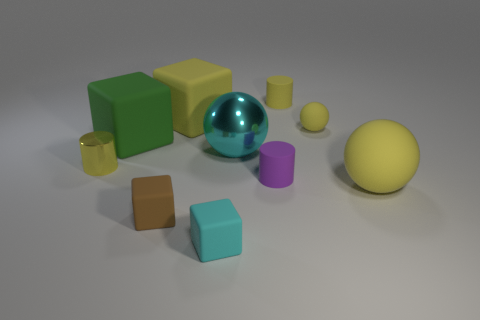Is the color of the tiny sphere the same as the small metal object?
Offer a terse response. Yes. How many small objects are blue cubes or purple cylinders?
Keep it short and to the point. 1. How many other yellow metal objects are the same shape as the yellow metal thing?
Your answer should be compact. 0. Do the tiny yellow shiny object and the small matte object behind the yellow block have the same shape?
Your answer should be very brief. Yes. How many tiny rubber things are behind the yellow cube?
Ensure brevity in your answer.  1. Are there any matte spheres of the same size as the cyan shiny sphere?
Your answer should be compact. Yes. Do the tiny object on the left side of the tiny brown thing and the purple matte object have the same shape?
Give a very brief answer. Yes. What is the color of the big matte ball?
Your response must be concise. Yellow. What is the shape of the small matte object that is the same color as the big metal ball?
Provide a succinct answer. Cube. Are any matte objects visible?
Offer a terse response. Yes. 